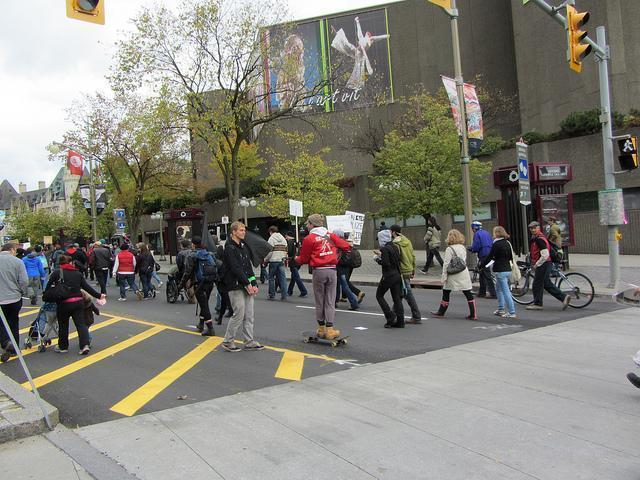What type of area is shown?
From the following four choices, select the correct answer to address the question.
Options: Public, rural, residential, private. Public. 